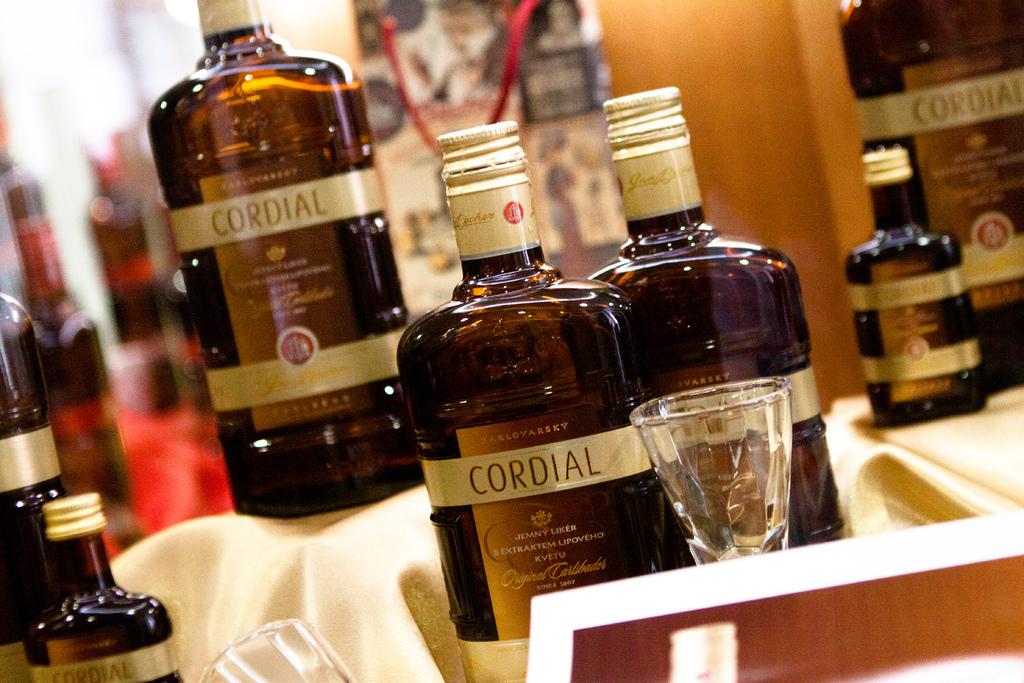What type of drink is this?
Provide a short and direct response. Cordial. 